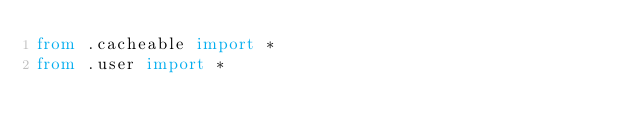Convert code to text. <code><loc_0><loc_0><loc_500><loc_500><_Python_>from .cacheable import *
from .user import *
</code> 